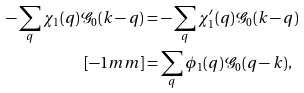Convert formula to latex. <formula><loc_0><loc_0><loc_500><loc_500>- \sum _ { q } \chi _ { 1 } ( q ) \mathcal { G } _ { 0 } ( k - q ) & = - \sum _ { q } \chi _ { 1 } ^ { \prime } ( q ) \mathcal { G } _ { 0 } ( k - q ) \\ [ - 1 m m ] & = \sum _ { q } \phi _ { 1 } ( q ) \mathcal { G } _ { 0 } ( q - k ) ,</formula> 